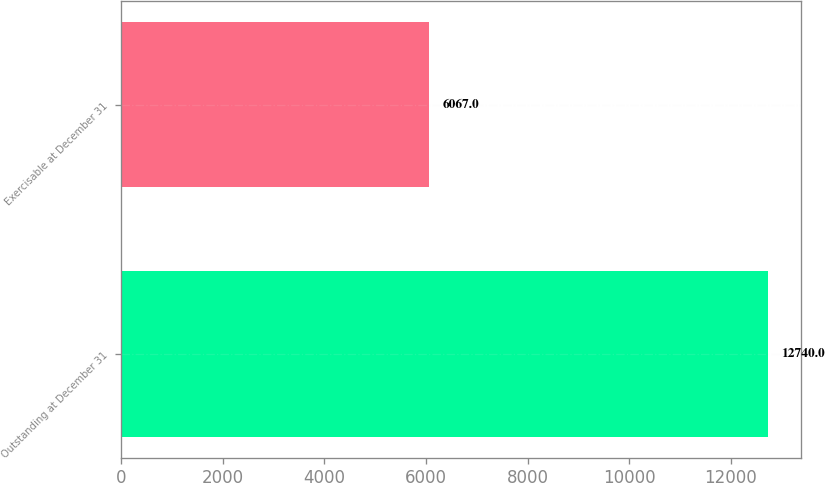Convert chart. <chart><loc_0><loc_0><loc_500><loc_500><bar_chart><fcel>Outstanding at December 31<fcel>Exercisable at December 31<nl><fcel>12740<fcel>6067<nl></chart> 